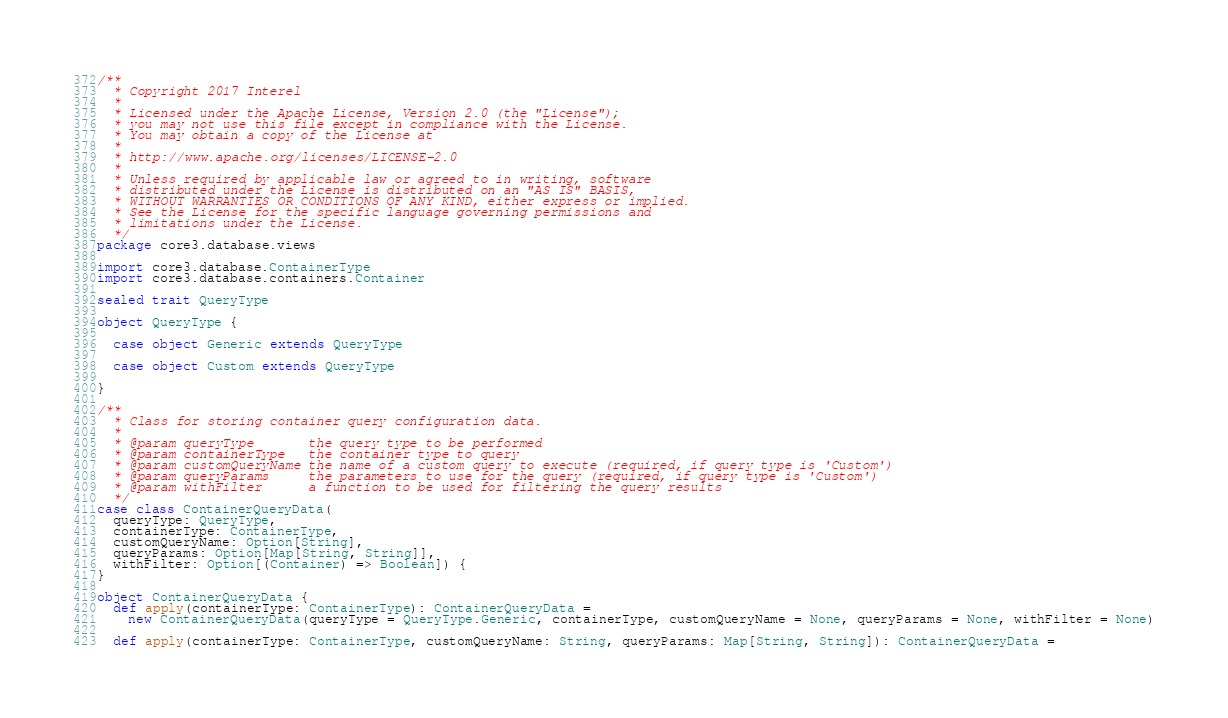<code> <loc_0><loc_0><loc_500><loc_500><_Scala_>/**
  * Copyright 2017 Interel
  *
  * Licensed under the Apache License, Version 2.0 (the "License");
  * you may not use this file except in compliance with the License.
  * You may obtain a copy of the License at
  *
  * http://www.apache.org/licenses/LICENSE-2.0
  *
  * Unless required by applicable law or agreed to in writing, software
  * distributed under the License is distributed on an "AS IS" BASIS,
  * WITHOUT WARRANTIES OR CONDITIONS OF ANY KIND, either express or implied.
  * See the License for the specific language governing permissions and
  * limitations under the License.
  */
package core3.database.views

import core3.database.ContainerType
import core3.database.containers.Container

sealed trait QueryType

object QueryType {

  case object Generic extends QueryType

  case object Custom extends QueryType

}

/**
  * Class for storing container query configuration data.
  *
  * @param queryType       the query type to be performed
  * @param containerType   the container type to query
  * @param customQueryName the name of a custom query to execute (required, if query type is 'Custom')
  * @param queryParams     the parameters to use for the query (required, if query type is 'Custom')
  * @param withFilter      a function to be used for filtering the query results
  */
case class ContainerQueryData(
  queryType: QueryType,
  containerType: ContainerType,
  customQueryName: Option[String],
  queryParams: Option[Map[String, String]],
  withFilter: Option[(Container) => Boolean]) {
}

object ContainerQueryData {
  def apply(containerType: ContainerType): ContainerQueryData =
    new ContainerQueryData(queryType = QueryType.Generic, containerType, customQueryName = None, queryParams = None, withFilter = None)

  def apply(containerType: ContainerType, customQueryName: String, queryParams: Map[String, String]): ContainerQueryData =</code> 